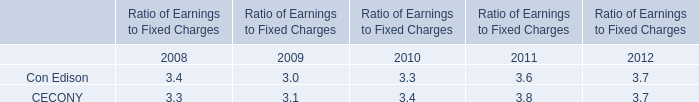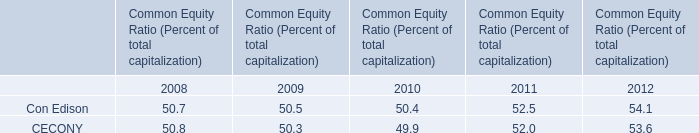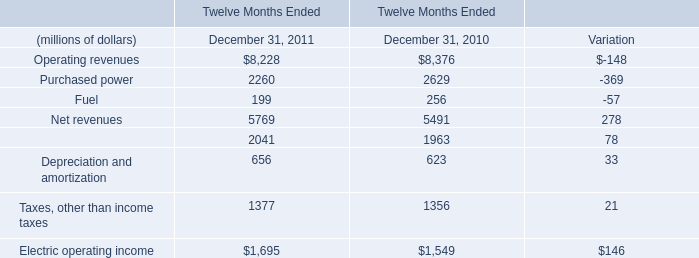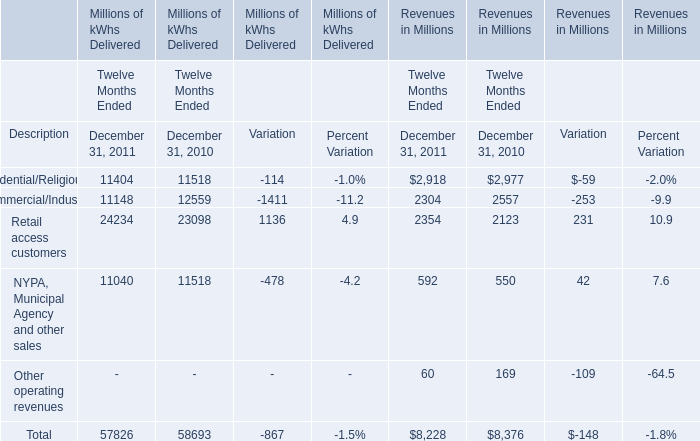what's the total amount of Commercial/Industrial of Millions of kWhs Delivered Variation, and Electric operating income of Twelve Months Ended December 31, 2011 ? 
Computations: (1411.0 + 1695.0)
Answer: 3106.0. 